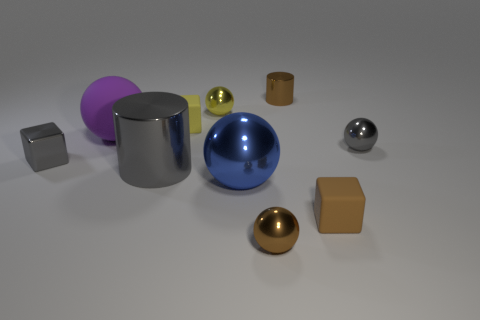Subtract all gray spheres. How many spheres are left? 4 Subtract all brown spheres. How many spheres are left? 4 Subtract all cubes. How many objects are left? 7 Subtract 2 cylinders. How many cylinders are left? 0 Subtract all blue metal cubes. Subtract all purple matte objects. How many objects are left? 9 Add 7 blocks. How many blocks are left? 10 Add 8 large purple matte blocks. How many large purple matte blocks exist? 8 Subtract 0 purple blocks. How many objects are left? 10 Subtract all blue balls. Subtract all red cubes. How many balls are left? 4 Subtract all yellow balls. How many red blocks are left? 0 